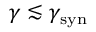<formula> <loc_0><loc_0><loc_500><loc_500>\gamma \lesssim \gamma _ { s y n }</formula> 